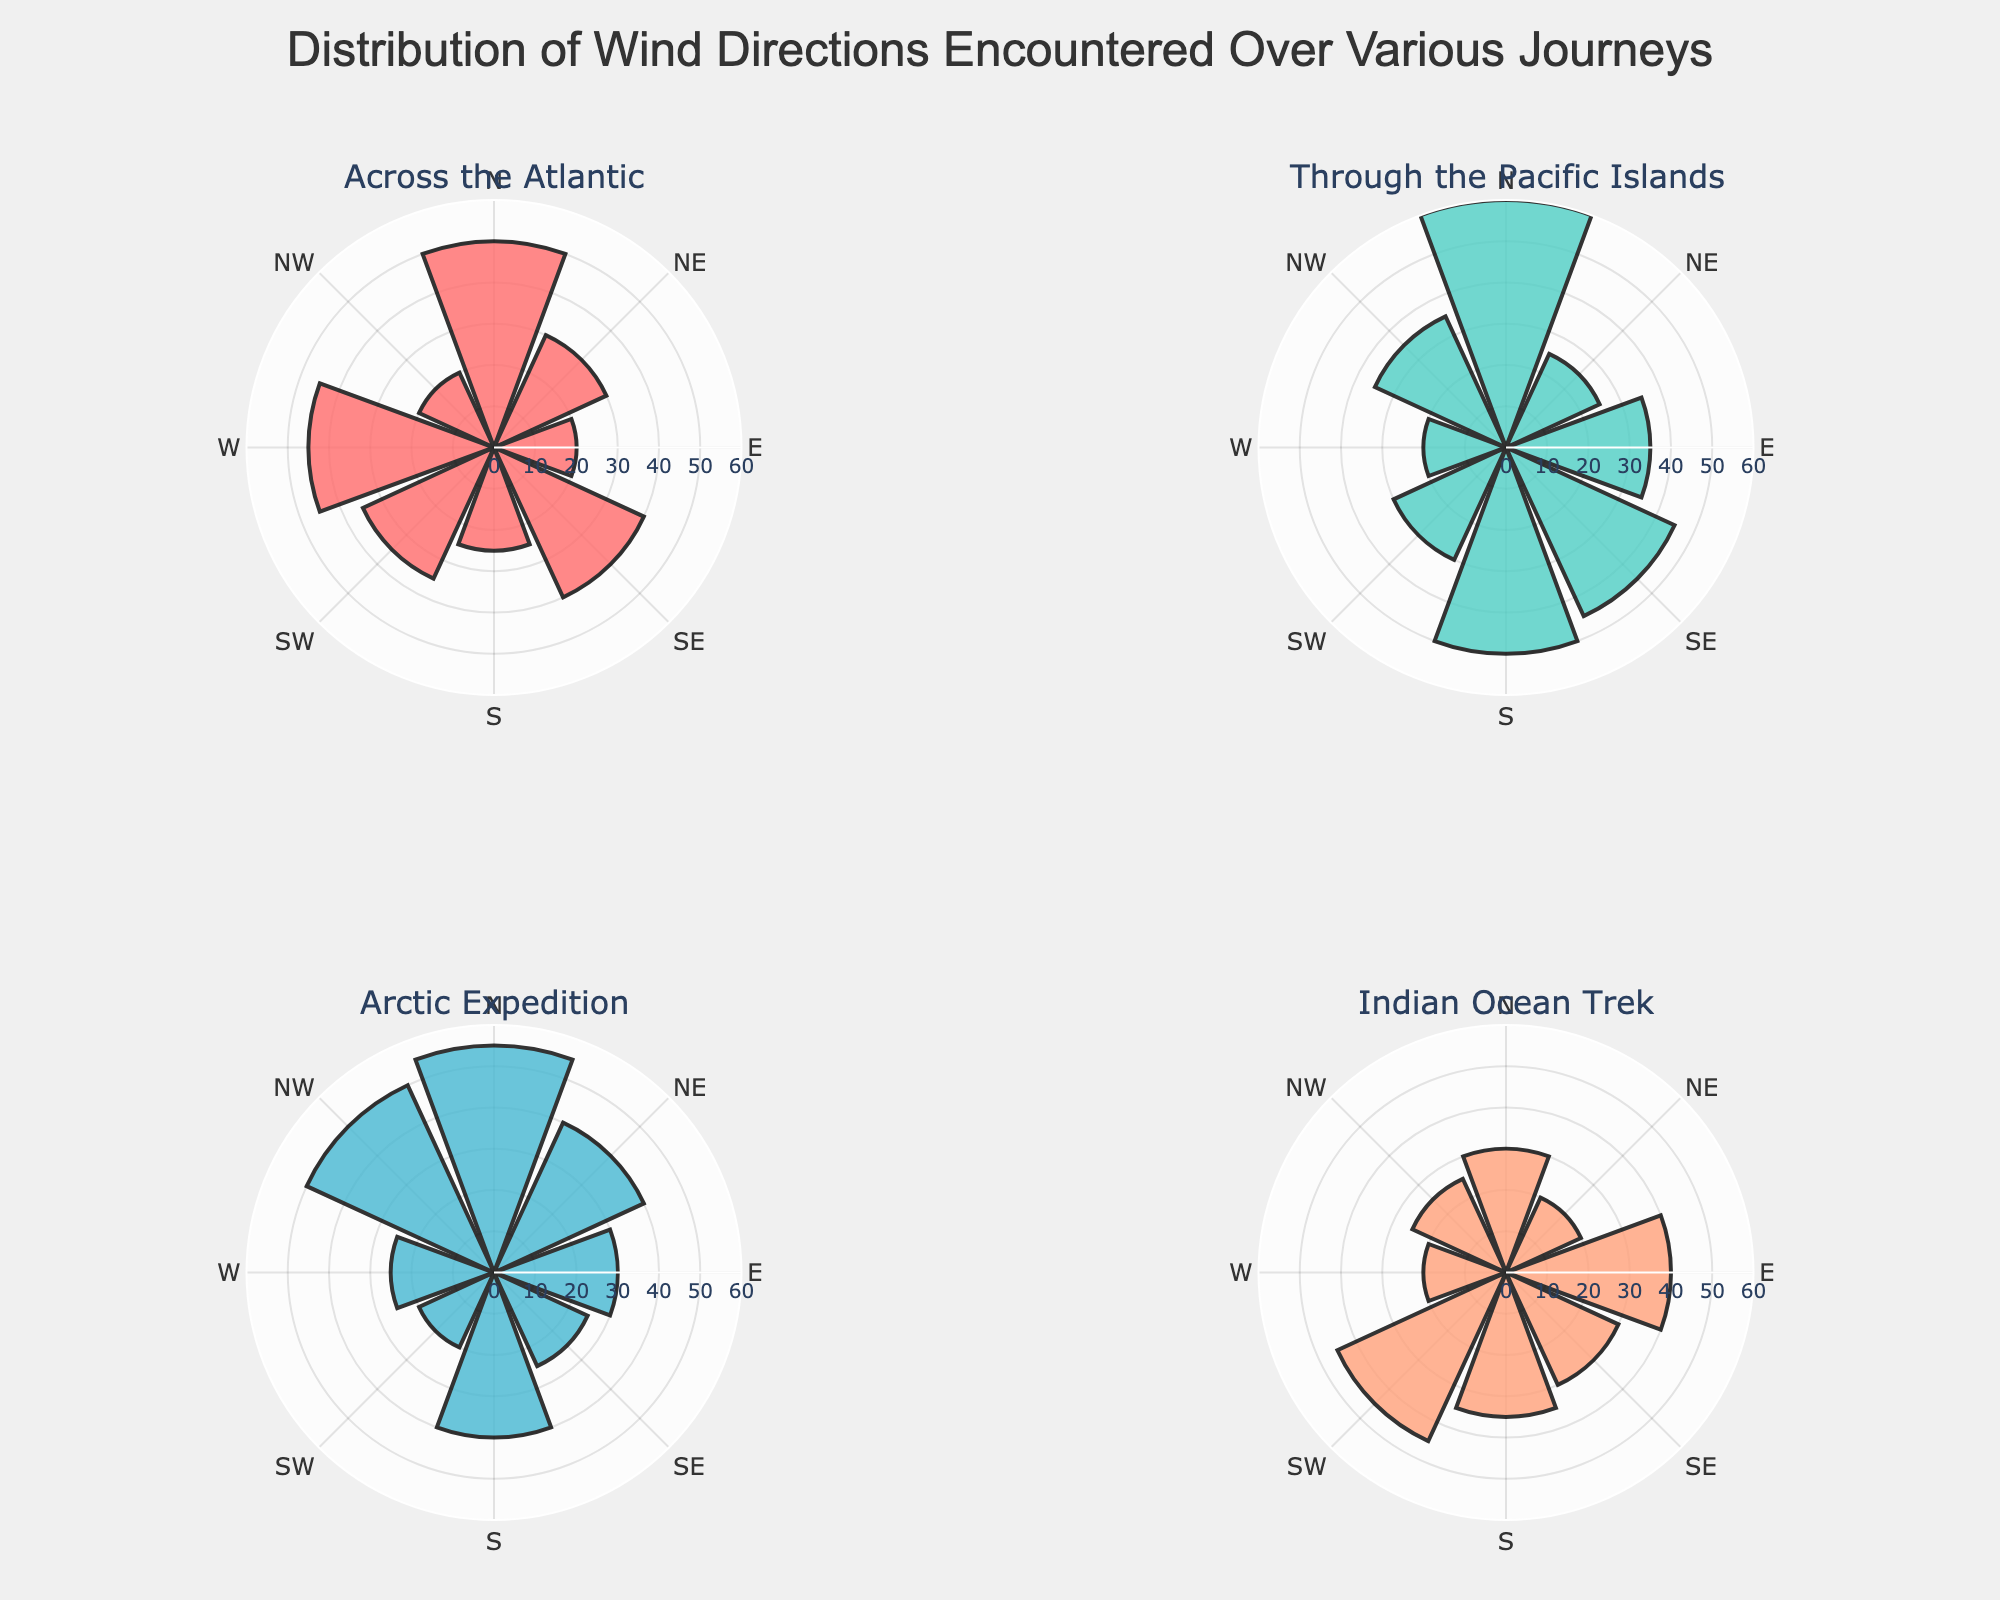what is the title of this figure? The title is displayed at the top center of the figure. It reads "Distribution of Wind Directions Encountered Over Various Journeys."
Answer: Distribution of Wind Directions Encountered Over Various Journeys How many unique journeys are displayed in the figure? The figure contains subplots for different journeys. By counting the subplot titles, we see there are four unique journeys: "Across the Atlantic", "Through the Pacific Islands", "Arctic Expedition", and "Indian Ocean Trek."
Answer: 4 Which journey encountered the highest count of wind coming from the North? By examining the counts in each subplot, the subplot for "Through the Pacific Islands" shows the highest count of wind from the North, which is 60.
Answer: Through the Pacific Islands What is the count of wind from the East during the Arctic Expedition? Focus on the "Arctic Expedition" subplot and locate the bar corresponding to the East direction. The count is 30.
Answer: 30 Which direction has the lowest count of wind for the Indian Ocean Trek? For the "Indian Ocean Trek" subplot, the direction with the smallest bar is West, with a count of 20.
Answer: West Compare the counts of wind from the Southeast across all journeys. Which journey has the highest count? Look at the Southeast direction in each subplot. "Through the Pacific Islands" has the highest count with 45.
Answer: Through the Pacific Islands What's the average count of wind from the Northwest direction across all journeys? Sum the counts from the Northwest direction (20 + 35 + 50 + 25 = 130), then divide by the number of journeys (4). The average is 130/4 = 32.5
Answer: 32.5 In which journey is the difference between the maximum and minimum wind direction counts the highest? Calculate the difference between the maximum and minimum counts for each subplot. The "Arctic Expedition" shows the highest difference: (55 - 20 = 35).
Answer: Arctic Expedition 